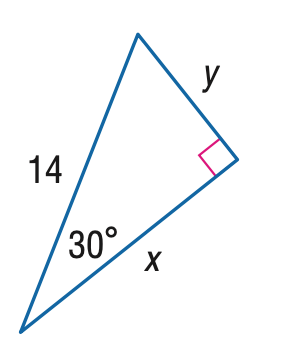Answer the mathemtical geometry problem and directly provide the correct option letter.
Question: Find x.
Choices: A: 7 B: 7 \sqrt { 2 } C: 7 \sqrt { 3 } D: 14 C 